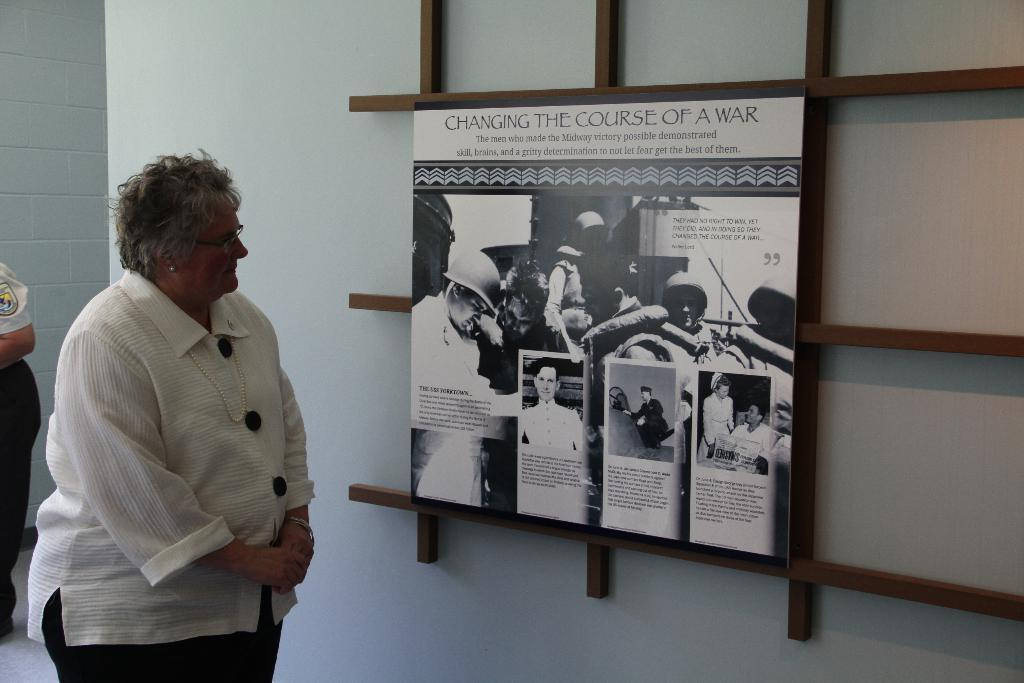Who is present in the image? There is a woman in the image. Where is the woman located in the image? The woman is standing at the left side. What is the woman wearing in the image? The woman is wearing a white shirt and black pants. What can be seen in the image besides the woman? There is a photo frame in the image. What is the background of the image? There is a white wall in the background of the image. What time of day is it in the image, and how many sheep are present? The time of day is not mentioned in the image, and there are no sheep present. 